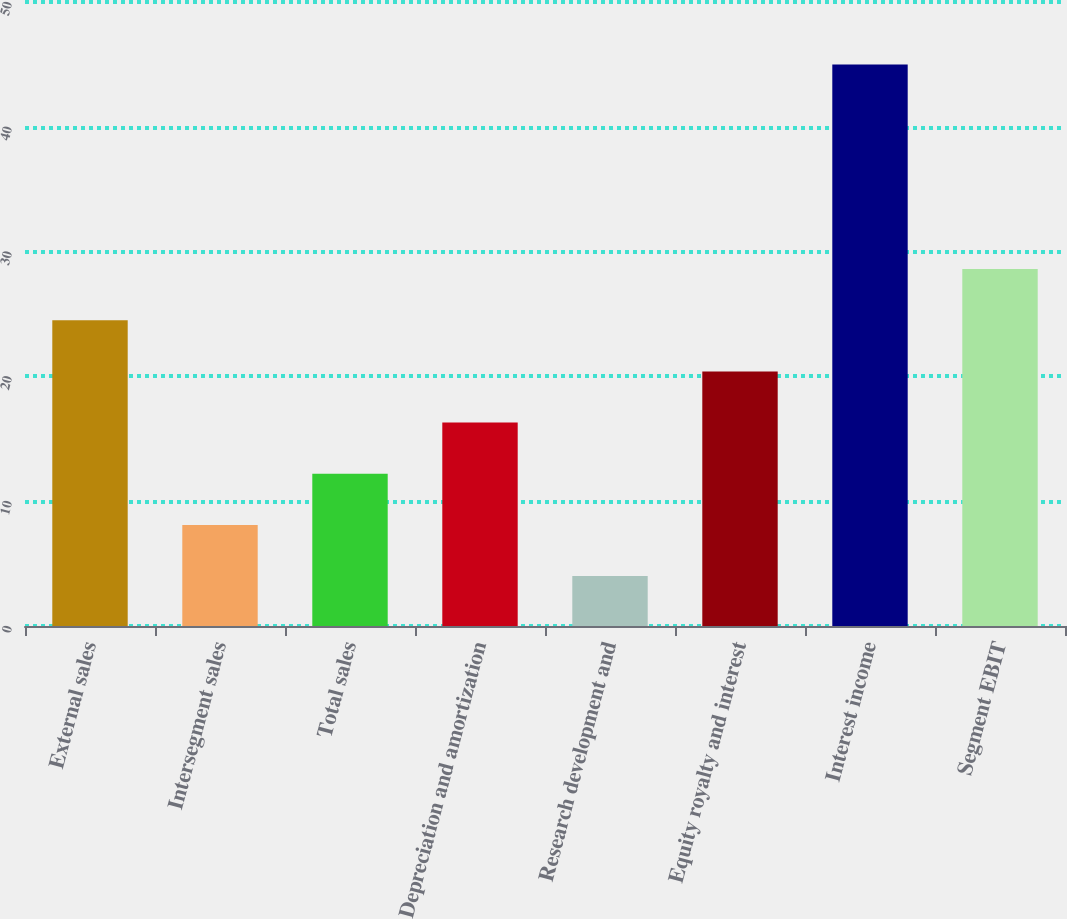<chart> <loc_0><loc_0><loc_500><loc_500><bar_chart><fcel>External sales<fcel>Intersegment sales<fcel>Total sales<fcel>Depreciation and amortization<fcel>Research development and<fcel>Equity royalty and interest<fcel>Interest income<fcel>Segment EBIT<nl><fcel>24.5<fcel>8.1<fcel>12.2<fcel>16.3<fcel>4<fcel>20.4<fcel>45<fcel>28.6<nl></chart> 